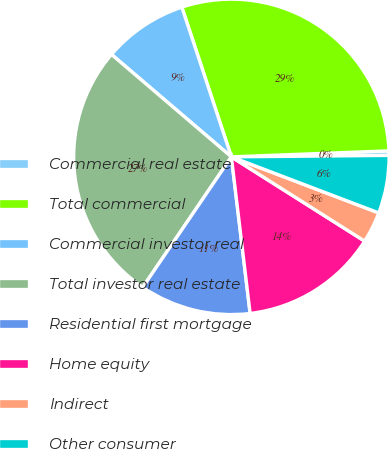Convert chart to OTSL. <chart><loc_0><loc_0><loc_500><loc_500><pie_chart><fcel>Commercial real estate<fcel>Total commercial<fcel>Commercial investor real<fcel>Total investor real estate<fcel>Residential first mortgage<fcel>Home equity<fcel>Indirect<fcel>Other consumer<nl><fcel>0.46%<fcel>29.48%<fcel>8.66%<fcel>26.75%<fcel>11.4%<fcel>14.13%<fcel>3.19%<fcel>5.93%<nl></chart> 